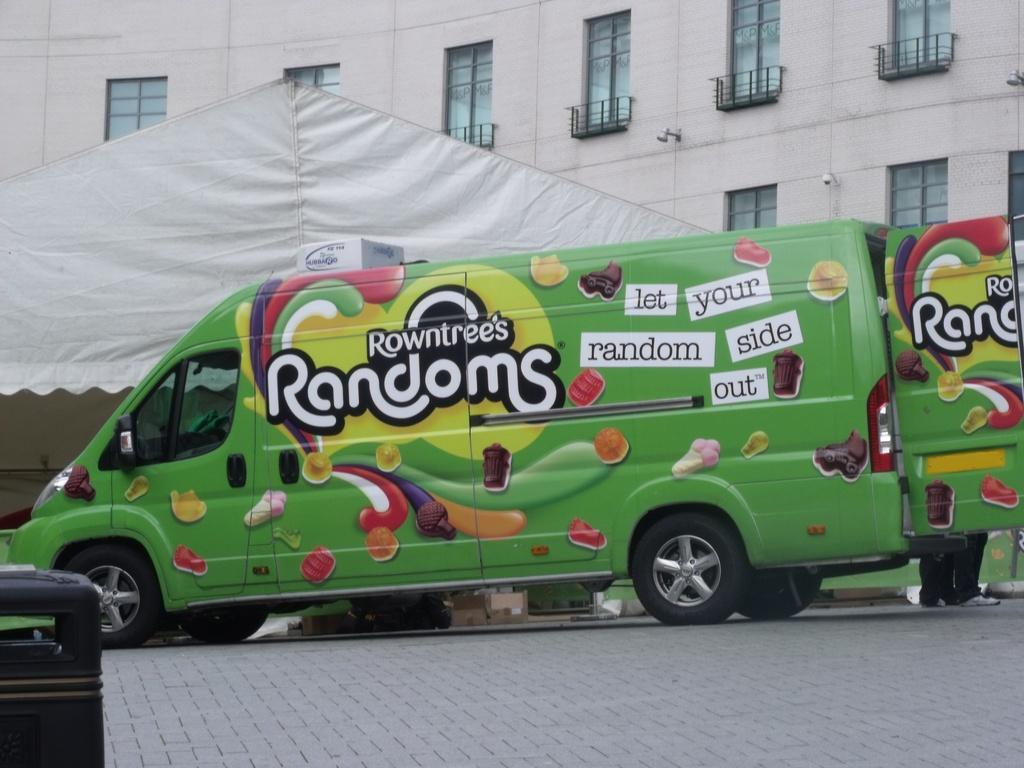In one or two sentences, can you explain what this image depicts? In this image, we can see a truck on the path. In the bottom left corner, there is a dustbin. In the background, we can see the tent, carton boxes, building, wall, glass objects, railings, lights, some objects and legs of a people. 